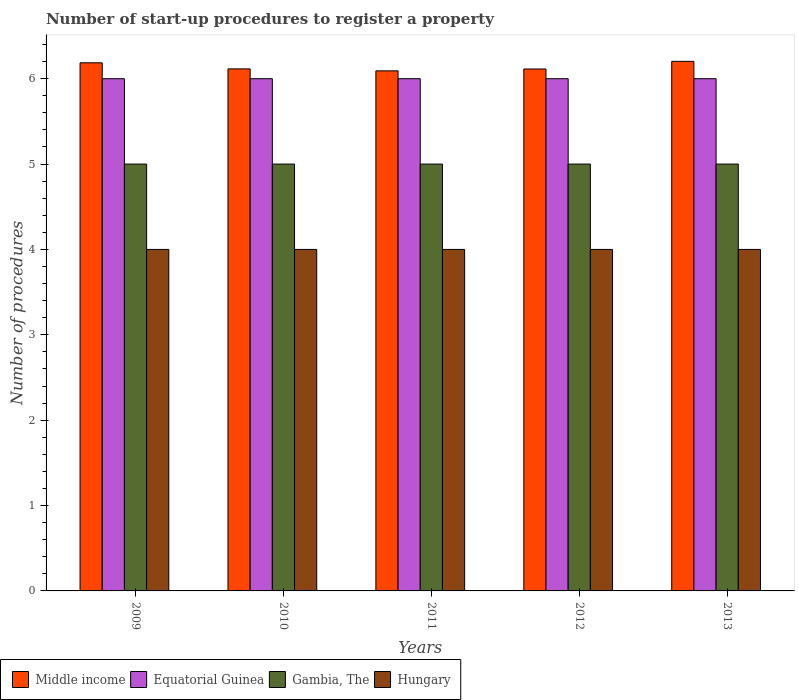How many different coloured bars are there?
Provide a short and direct response. 4. How many groups of bars are there?
Provide a short and direct response. 5. Are the number of bars per tick equal to the number of legend labels?
Offer a terse response. Yes. How many bars are there on the 1st tick from the left?
Provide a succinct answer. 4. How many bars are there on the 1st tick from the right?
Your answer should be compact. 4. What is the label of the 5th group of bars from the left?
Your answer should be compact. 2013. In how many cases, is the number of bars for a given year not equal to the number of legend labels?
Your answer should be very brief. 0. What is the number of procedures required to register a property in Gambia, The in 2013?
Give a very brief answer. 5. Across all years, what is the minimum number of procedures required to register a property in Middle income?
Give a very brief answer. 6.09. In which year was the number of procedures required to register a property in Equatorial Guinea maximum?
Make the answer very short. 2009. What is the difference between the number of procedures required to register a property in Middle income in 2009 and that in 2013?
Your answer should be very brief. -0.02. What is the difference between the number of procedures required to register a property in Hungary in 2010 and the number of procedures required to register a property in Middle income in 2009?
Ensure brevity in your answer.  -2.19. What is the average number of procedures required to register a property in Middle income per year?
Provide a short and direct response. 6.14. Is the number of procedures required to register a property in Middle income in 2010 less than that in 2011?
Provide a succinct answer. No. Is the difference between the number of procedures required to register a property in Gambia, The in 2009 and 2013 greater than the difference between the number of procedures required to register a property in Equatorial Guinea in 2009 and 2013?
Give a very brief answer. No. What is the difference between the highest and the second highest number of procedures required to register a property in Equatorial Guinea?
Your answer should be very brief. 0. What is the difference between the highest and the lowest number of procedures required to register a property in Hungary?
Provide a short and direct response. 0. In how many years, is the number of procedures required to register a property in Middle income greater than the average number of procedures required to register a property in Middle income taken over all years?
Keep it short and to the point. 2. What does the 4th bar from the left in 2013 represents?
Provide a succinct answer. Hungary. Is it the case that in every year, the sum of the number of procedures required to register a property in Middle income and number of procedures required to register a property in Gambia, The is greater than the number of procedures required to register a property in Equatorial Guinea?
Make the answer very short. Yes. How many bars are there?
Your answer should be very brief. 20. How many years are there in the graph?
Offer a terse response. 5. What is the difference between two consecutive major ticks on the Y-axis?
Offer a terse response. 1. Does the graph contain any zero values?
Your response must be concise. No. Does the graph contain grids?
Keep it short and to the point. No. Where does the legend appear in the graph?
Your answer should be very brief. Bottom left. What is the title of the graph?
Offer a very short reply. Number of start-up procedures to register a property. Does "Kuwait" appear as one of the legend labels in the graph?
Keep it short and to the point. No. What is the label or title of the X-axis?
Ensure brevity in your answer.  Years. What is the label or title of the Y-axis?
Provide a short and direct response. Number of procedures. What is the Number of procedures in Middle income in 2009?
Give a very brief answer. 6.19. What is the Number of procedures of Middle income in 2010?
Your answer should be very brief. 6.11. What is the Number of procedures of Equatorial Guinea in 2010?
Make the answer very short. 6. What is the Number of procedures in Middle income in 2011?
Ensure brevity in your answer.  6.09. What is the Number of procedures of Gambia, The in 2011?
Your answer should be compact. 5. What is the Number of procedures in Hungary in 2011?
Your answer should be very brief. 4. What is the Number of procedures of Middle income in 2012?
Provide a succinct answer. 6.11. What is the Number of procedures of Gambia, The in 2012?
Your answer should be compact. 5. What is the Number of procedures of Middle income in 2013?
Keep it short and to the point. 6.2. What is the Number of procedures of Equatorial Guinea in 2013?
Your response must be concise. 6. What is the Number of procedures in Hungary in 2013?
Provide a succinct answer. 4. Across all years, what is the maximum Number of procedures in Middle income?
Provide a short and direct response. 6.2. Across all years, what is the maximum Number of procedures of Equatorial Guinea?
Provide a short and direct response. 6. Across all years, what is the maximum Number of procedures in Hungary?
Offer a terse response. 4. Across all years, what is the minimum Number of procedures of Middle income?
Offer a very short reply. 6.09. Across all years, what is the minimum Number of procedures in Equatorial Guinea?
Give a very brief answer. 6. Across all years, what is the minimum Number of procedures of Hungary?
Your answer should be compact. 4. What is the total Number of procedures in Middle income in the graph?
Your response must be concise. 30.71. What is the total Number of procedures in Equatorial Guinea in the graph?
Provide a short and direct response. 30. What is the total Number of procedures of Gambia, The in the graph?
Your answer should be very brief. 25. What is the total Number of procedures of Hungary in the graph?
Offer a very short reply. 20. What is the difference between the Number of procedures in Middle income in 2009 and that in 2010?
Give a very brief answer. 0.07. What is the difference between the Number of procedures of Equatorial Guinea in 2009 and that in 2010?
Give a very brief answer. 0. What is the difference between the Number of procedures of Hungary in 2009 and that in 2010?
Offer a very short reply. 0. What is the difference between the Number of procedures of Middle income in 2009 and that in 2011?
Make the answer very short. 0.09. What is the difference between the Number of procedures in Gambia, The in 2009 and that in 2011?
Offer a very short reply. 0. What is the difference between the Number of procedures of Middle income in 2009 and that in 2012?
Make the answer very short. 0.07. What is the difference between the Number of procedures of Hungary in 2009 and that in 2012?
Keep it short and to the point. 0. What is the difference between the Number of procedures of Middle income in 2009 and that in 2013?
Make the answer very short. -0.02. What is the difference between the Number of procedures in Equatorial Guinea in 2009 and that in 2013?
Offer a terse response. 0. What is the difference between the Number of procedures in Middle income in 2010 and that in 2011?
Provide a succinct answer. 0.02. What is the difference between the Number of procedures in Gambia, The in 2010 and that in 2011?
Your answer should be very brief. 0. What is the difference between the Number of procedures in Hungary in 2010 and that in 2011?
Make the answer very short. 0. What is the difference between the Number of procedures in Middle income in 2010 and that in 2012?
Offer a terse response. 0. What is the difference between the Number of procedures of Hungary in 2010 and that in 2012?
Provide a short and direct response. 0. What is the difference between the Number of procedures in Middle income in 2010 and that in 2013?
Your answer should be compact. -0.09. What is the difference between the Number of procedures in Equatorial Guinea in 2010 and that in 2013?
Ensure brevity in your answer.  0. What is the difference between the Number of procedures of Hungary in 2010 and that in 2013?
Your response must be concise. 0. What is the difference between the Number of procedures in Middle income in 2011 and that in 2012?
Your answer should be compact. -0.02. What is the difference between the Number of procedures in Gambia, The in 2011 and that in 2012?
Keep it short and to the point. 0. What is the difference between the Number of procedures of Hungary in 2011 and that in 2012?
Provide a short and direct response. 0. What is the difference between the Number of procedures of Middle income in 2011 and that in 2013?
Offer a terse response. -0.11. What is the difference between the Number of procedures of Equatorial Guinea in 2011 and that in 2013?
Ensure brevity in your answer.  0. What is the difference between the Number of procedures in Middle income in 2012 and that in 2013?
Your response must be concise. -0.09. What is the difference between the Number of procedures of Gambia, The in 2012 and that in 2013?
Provide a succinct answer. 0. What is the difference between the Number of procedures of Hungary in 2012 and that in 2013?
Make the answer very short. 0. What is the difference between the Number of procedures of Middle income in 2009 and the Number of procedures of Equatorial Guinea in 2010?
Provide a short and direct response. 0.19. What is the difference between the Number of procedures of Middle income in 2009 and the Number of procedures of Gambia, The in 2010?
Your answer should be very brief. 1.19. What is the difference between the Number of procedures of Middle income in 2009 and the Number of procedures of Hungary in 2010?
Ensure brevity in your answer.  2.19. What is the difference between the Number of procedures in Gambia, The in 2009 and the Number of procedures in Hungary in 2010?
Give a very brief answer. 1. What is the difference between the Number of procedures of Middle income in 2009 and the Number of procedures of Equatorial Guinea in 2011?
Provide a short and direct response. 0.19. What is the difference between the Number of procedures of Middle income in 2009 and the Number of procedures of Gambia, The in 2011?
Your answer should be compact. 1.19. What is the difference between the Number of procedures of Middle income in 2009 and the Number of procedures of Hungary in 2011?
Offer a terse response. 2.19. What is the difference between the Number of procedures of Middle income in 2009 and the Number of procedures of Equatorial Guinea in 2012?
Provide a succinct answer. 0.19. What is the difference between the Number of procedures of Middle income in 2009 and the Number of procedures of Gambia, The in 2012?
Offer a terse response. 1.19. What is the difference between the Number of procedures in Middle income in 2009 and the Number of procedures in Hungary in 2012?
Your answer should be compact. 2.19. What is the difference between the Number of procedures in Equatorial Guinea in 2009 and the Number of procedures in Gambia, The in 2012?
Your answer should be compact. 1. What is the difference between the Number of procedures in Gambia, The in 2009 and the Number of procedures in Hungary in 2012?
Keep it short and to the point. 1. What is the difference between the Number of procedures of Middle income in 2009 and the Number of procedures of Equatorial Guinea in 2013?
Give a very brief answer. 0.19. What is the difference between the Number of procedures of Middle income in 2009 and the Number of procedures of Gambia, The in 2013?
Keep it short and to the point. 1.19. What is the difference between the Number of procedures of Middle income in 2009 and the Number of procedures of Hungary in 2013?
Your response must be concise. 2.19. What is the difference between the Number of procedures of Equatorial Guinea in 2009 and the Number of procedures of Hungary in 2013?
Your response must be concise. 2. What is the difference between the Number of procedures of Gambia, The in 2009 and the Number of procedures of Hungary in 2013?
Offer a terse response. 1. What is the difference between the Number of procedures of Middle income in 2010 and the Number of procedures of Equatorial Guinea in 2011?
Give a very brief answer. 0.11. What is the difference between the Number of procedures of Middle income in 2010 and the Number of procedures of Gambia, The in 2011?
Your answer should be compact. 1.11. What is the difference between the Number of procedures of Middle income in 2010 and the Number of procedures of Hungary in 2011?
Your answer should be very brief. 2.11. What is the difference between the Number of procedures of Equatorial Guinea in 2010 and the Number of procedures of Hungary in 2011?
Provide a short and direct response. 2. What is the difference between the Number of procedures in Middle income in 2010 and the Number of procedures in Equatorial Guinea in 2012?
Your response must be concise. 0.11. What is the difference between the Number of procedures of Middle income in 2010 and the Number of procedures of Gambia, The in 2012?
Keep it short and to the point. 1.11. What is the difference between the Number of procedures of Middle income in 2010 and the Number of procedures of Hungary in 2012?
Offer a terse response. 2.11. What is the difference between the Number of procedures of Middle income in 2010 and the Number of procedures of Equatorial Guinea in 2013?
Your response must be concise. 0.11. What is the difference between the Number of procedures in Middle income in 2010 and the Number of procedures in Gambia, The in 2013?
Provide a succinct answer. 1.11. What is the difference between the Number of procedures of Middle income in 2010 and the Number of procedures of Hungary in 2013?
Offer a very short reply. 2.11. What is the difference between the Number of procedures in Middle income in 2011 and the Number of procedures in Equatorial Guinea in 2012?
Offer a terse response. 0.09. What is the difference between the Number of procedures in Middle income in 2011 and the Number of procedures in Gambia, The in 2012?
Offer a terse response. 1.09. What is the difference between the Number of procedures in Middle income in 2011 and the Number of procedures in Hungary in 2012?
Your answer should be very brief. 2.09. What is the difference between the Number of procedures in Equatorial Guinea in 2011 and the Number of procedures in Gambia, The in 2012?
Make the answer very short. 1. What is the difference between the Number of procedures in Equatorial Guinea in 2011 and the Number of procedures in Hungary in 2012?
Provide a short and direct response. 2. What is the difference between the Number of procedures of Middle income in 2011 and the Number of procedures of Equatorial Guinea in 2013?
Give a very brief answer. 0.09. What is the difference between the Number of procedures of Middle income in 2011 and the Number of procedures of Gambia, The in 2013?
Your answer should be very brief. 1.09. What is the difference between the Number of procedures of Middle income in 2011 and the Number of procedures of Hungary in 2013?
Provide a succinct answer. 2.09. What is the difference between the Number of procedures of Equatorial Guinea in 2011 and the Number of procedures of Hungary in 2013?
Give a very brief answer. 2. What is the difference between the Number of procedures in Middle income in 2012 and the Number of procedures in Equatorial Guinea in 2013?
Give a very brief answer. 0.11. What is the difference between the Number of procedures of Middle income in 2012 and the Number of procedures of Gambia, The in 2013?
Keep it short and to the point. 1.11. What is the difference between the Number of procedures of Middle income in 2012 and the Number of procedures of Hungary in 2013?
Provide a short and direct response. 2.11. What is the difference between the Number of procedures of Equatorial Guinea in 2012 and the Number of procedures of Gambia, The in 2013?
Make the answer very short. 1. What is the average Number of procedures of Middle income per year?
Keep it short and to the point. 6.14. What is the average Number of procedures in Equatorial Guinea per year?
Your answer should be very brief. 6. What is the average Number of procedures of Gambia, The per year?
Give a very brief answer. 5. In the year 2009, what is the difference between the Number of procedures in Middle income and Number of procedures in Equatorial Guinea?
Offer a terse response. 0.19. In the year 2009, what is the difference between the Number of procedures of Middle income and Number of procedures of Gambia, The?
Offer a terse response. 1.19. In the year 2009, what is the difference between the Number of procedures of Middle income and Number of procedures of Hungary?
Your answer should be compact. 2.19. In the year 2009, what is the difference between the Number of procedures of Equatorial Guinea and Number of procedures of Gambia, The?
Provide a short and direct response. 1. In the year 2010, what is the difference between the Number of procedures in Middle income and Number of procedures in Equatorial Guinea?
Ensure brevity in your answer.  0.11. In the year 2010, what is the difference between the Number of procedures of Middle income and Number of procedures of Gambia, The?
Give a very brief answer. 1.11. In the year 2010, what is the difference between the Number of procedures in Middle income and Number of procedures in Hungary?
Offer a terse response. 2.11. In the year 2010, what is the difference between the Number of procedures in Equatorial Guinea and Number of procedures in Gambia, The?
Keep it short and to the point. 1. In the year 2010, what is the difference between the Number of procedures of Equatorial Guinea and Number of procedures of Hungary?
Provide a succinct answer. 2. In the year 2011, what is the difference between the Number of procedures of Middle income and Number of procedures of Equatorial Guinea?
Keep it short and to the point. 0.09. In the year 2011, what is the difference between the Number of procedures in Middle income and Number of procedures in Gambia, The?
Give a very brief answer. 1.09. In the year 2011, what is the difference between the Number of procedures in Middle income and Number of procedures in Hungary?
Your response must be concise. 2.09. In the year 2011, what is the difference between the Number of procedures of Equatorial Guinea and Number of procedures of Gambia, The?
Your answer should be very brief. 1. In the year 2011, what is the difference between the Number of procedures in Equatorial Guinea and Number of procedures in Hungary?
Your answer should be very brief. 2. In the year 2012, what is the difference between the Number of procedures in Middle income and Number of procedures in Equatorial Guinea?
Keep it short and to the point. 0.11. In the year 2012, what is the difference between the Number of procedures in Middle income and Number of procedures in Gambia, The?
Give a very brief answer. 1.11. In the year 2012, what is the difference between the Number of procedures in Middle income and Number of procedures in Hungary?
Provide a short and direct response. 2.11. In the year 2013, what is the difference between the Number of procedures of Middle income and Number of procedures of Equatorial Guinea?
Offer a very short reply. 0.2. In the year 2013, what is the difference between the Number of procedures of Middle income and Number of procedures of Gambia, The?
Offer a terse response. 1.2. In the year 2013, what is the difference between the Number of procedures in Middle income and Number of procedures in Hungary?
Provide a succinct answer. 2.2. In the year 2013, what is the difference between the Number of procedures in Equatorial Guinea and Number of procedures in Hungary?
Keep it short and to the point. 2. What is the ratio of the Number of procedures in Middle income in 2009 to that in 2010?
Provide a short and direct response. 1.01. What is the ratio of the Number of procedures in Gambia, The in 2009 to that in 2010?
Provide a succinct answer. 1. What is the ratio of the Number of procedures of Hungary in 2009 to that in 2010?
Provide a succinct answer. 1. What is the ratio of the Number of procedures of Middle income in 2009 to that in 2011?
Provide a succinct answer. 1.02. What is the ratio of the Number of procedures in Equatorial Guinea in 2009 to that in 2011?
Keep it short and to the point. 1. What is the ratio of the Number of procedures in Gambia, The in 2009 to that in 2011?
Your answer should be very brief. 1. What is the ratio of the Number of procedures in Middle income in 2009 to that in 2012?
Provide a succinct answer. 1.01. What is the ratio of the Number of procedures of Equatorial Guinea in 2009 to that in 2012?
Ensure brevity in your answer.  1. What is the ratio of the Number of procedures of Gambia, The in 2009 to that in 2012?
Offer a terse response. 1. What is the ratio of the Number of procedures in Middle income in 2009 to that in 2013?
Ensure brevity in your answer.  1. What is the ratio of the Number of procedures in Hungary in 2009 to that in 2013?
Your answer should be compact. 1. What is the ratio of the Number of procedures in Middle income in 2010 to that in 2011?
Your answer should be very brief. 1. What is the ratio of the Number of procedures in Equatorial Guinea in 2010 to that in 2011?
Offer a terse response. 1. What is the ratio of the Number of procedures of Gambia, The in 2010 to that in 2011?
Provide a succinct answer. 1. What is the ratio of the Number of procedures of Hungary in 2010 to that in 2011?
Provide a succinct answer. 1. What is the ratio of the Number of procedures of Middle income in 2010 to that in 2012?
Provide a succinct answer. 1. What is the ratio of the Number of procedures in Middle income in 2010 to that in 2013?
Your answer should be very brief. 0.99. What is the ratio of the Number of procedures of Equatorial Guinea in 2010 to that in 2013?
Your answer should be compact. 1. What is the ratio of the Number of procedures of Gambia, The in 2010 to that in 2013?
Ensure brevity in your answer.  1. What is the ratio of the Number of procedures of Gambia, The in 2011 to that in 2012?
Offer a very short reply. 1. What is the ratio of the Number of procedures in Middle income in 2011 to that in 2013?
Make the answer very short. 0.98. What is the ratio of the Number of procedures of Gambia, The in 2011 to that in 2013?
Offer a very short reply. 1. What is the ratio of the Number of procedures of Middle income in 2012 to that in 2013?
Offer a very short reply. 0.99. What is the ratio of the Number of procedures of Equatorial Guinea in 2012 to that in 2013?
Ensure brevity in your answer.  1. What is the ratio of the Number of procedures in Hungary in 2012 to that in 2013?
Your answer should be very brief. 1. What is the difference between the highest and the second highest Number of procedures in Middle income?
Ensure brevity in your answer.  0.02. What is the difference between the highest and the second highest Number of procedures of Equatorial Guinea?
Offer a very short reply. 0. What is the difference between the highest and the second highest Number of procedures of Gambia, The?
Give a very brief answer. 0. What is the difference between the highest and the lowest Number of procedures in Middle income?
Provide a succinct answer. 0.11. What is the difference between the highest and the lowest Number of procedures of Gambia, The?
Provide a short and direct response. 0. What is the difference between the highest and the lowest Number of procedures of Hungary?
Your answer should be very brief. 0. 